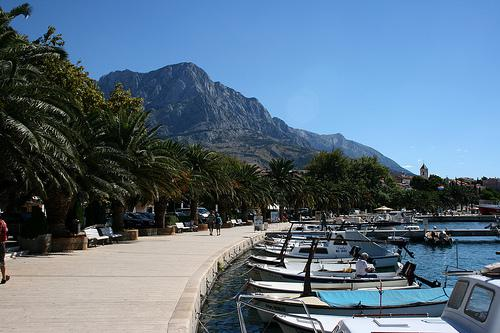Question: why are the people on the sidewalks?
Choices:
A. Running.
B. Dancing.
C. Walking.
D. Driving.
Answer with the letter. Answer: C Question: what type of trees?
Choices:
A. Oak trees.
B. Pine trees.
C. Maple trees.
D. Palm trees.
Answer with the letter. Answer: D Question: where are the boats?
Choices:
A. On the dock.
B. In storage.
C. In the water.
D. On a truck.
Answer with the letter. Answer: C Question: who is on the boat?
Choices:
A. A woman.
B. A man.
C. A young girl.
D. A young boy.
Answer with the letter. Answer: B 